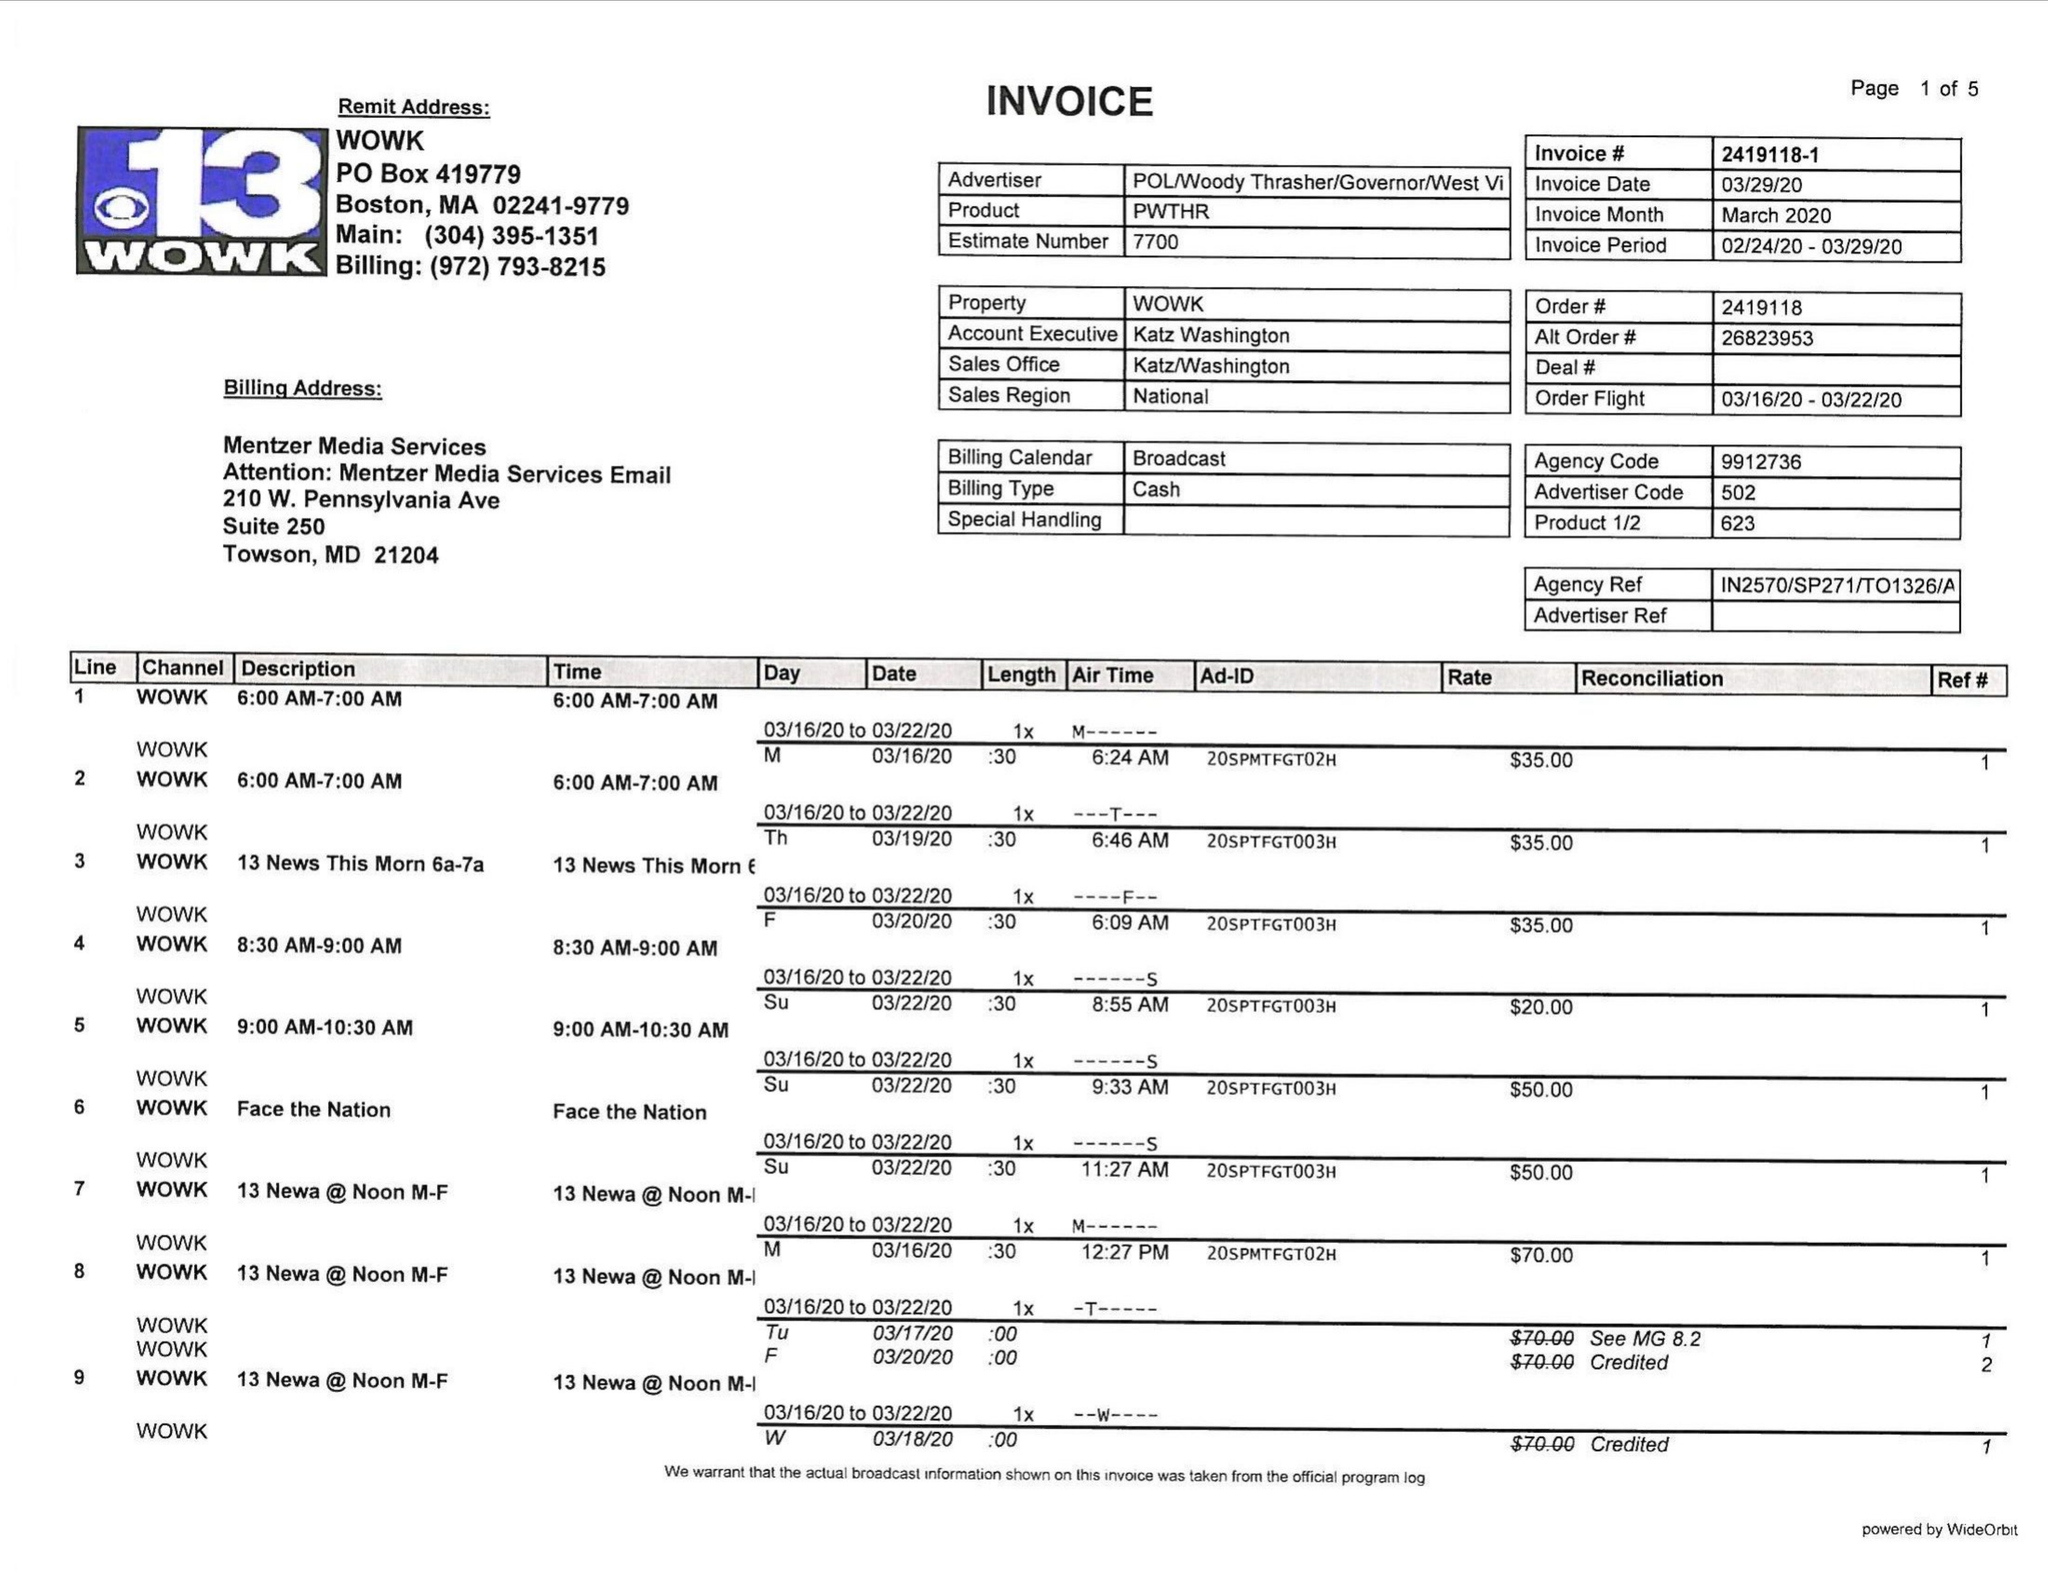What is the value for the flight_to?
Answer the question using a single word or phrase. 03/22/20 